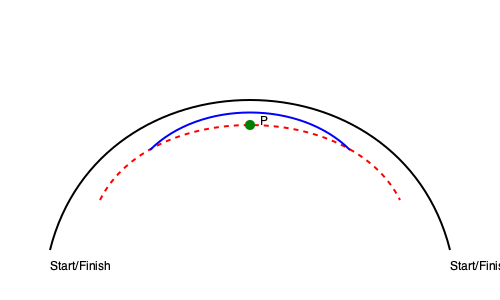In the diagram above, three different overtaking trajectories are shown for a corner in a Super GT race. The red dashed line represents the standard racing line, while the blue and black lines show alternative overtaking paths. At point P, what is the primary advantage of the blue line over the red line in terms of overtaking potential? To analyze the overtaking potential at point P, we need to consider several factors:

1. Racing line: The red dashed line represents the standard racing line, which is typically the fastest way around the corner.

2. Alternative lines: The blue and black lines show alternative paths that a driver might take when attempting an overtake.

3. Apex point: Point P appears to be near the apex of the corner, which is a critical point for overtaking.

4. Line comparison at point P:
   - The blue line is tighter (closer to the inside of the corner) than the red line at point P.
   - The black line is wider than both the red and blue lines.

5. Overtaking advantages of the blue line:
   - By taking a tighter line, the blue trajectory allows for a shorter distance traveled through the corner.
   - The tighter line positions the overtaking car to the inside of the defending car (on the red line), which is generally considered the preferred position for completing a pass.
   - The inside line gives the overtaking driver the opportunity to control the corner exit by potentially forcing the defending car to take a wider, longer path.

6. Trade-offs:
   - While the blue line offers positional advantages, it may require a lower entry speed due to the tighter radius.
   - The red line likely allows for higher corner entry speeds but leaves the door open for an inside pass.

In Super GT racing, where close battles and precise driving are crucial, the ability to position the car for an overtake on the inside line can be a significant advantage, especially if the driver can maintain a competitive speed through the corner.
Answer: Inside line positioning for overtaking 